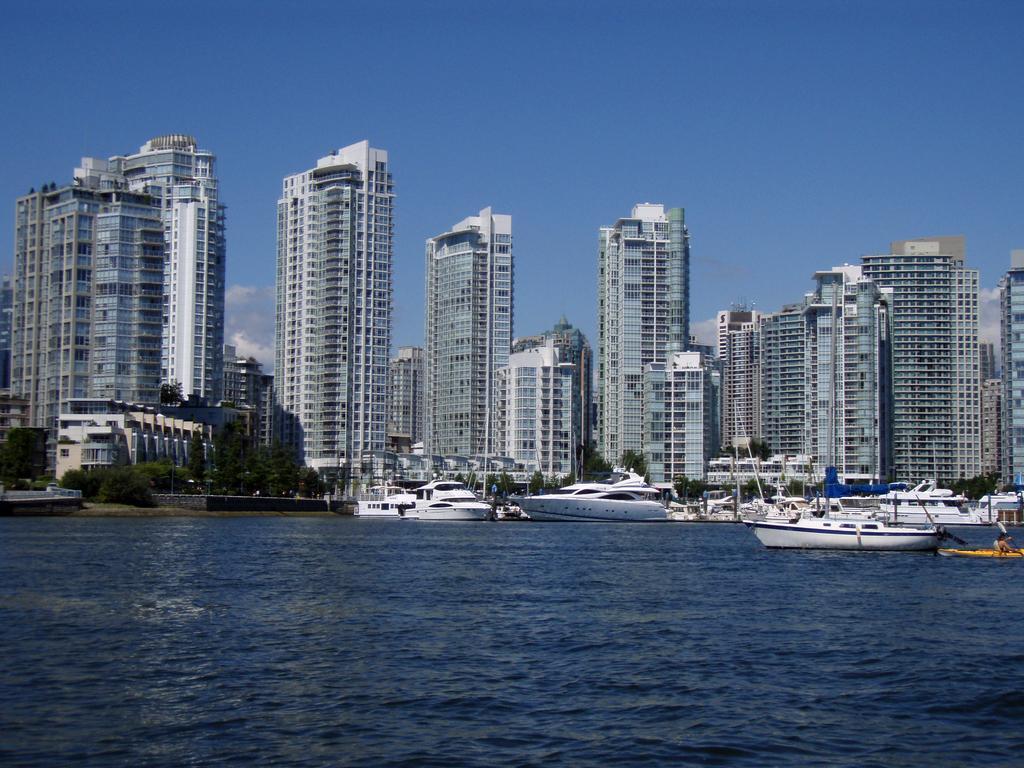How would you summarize this image in a sentence or two? This picture is clicked outside. In the center we can see the boats and ships in the water body and we can see the trees and plants. In the background we can see the sky, buildings, skyscrapers and some other objects. 